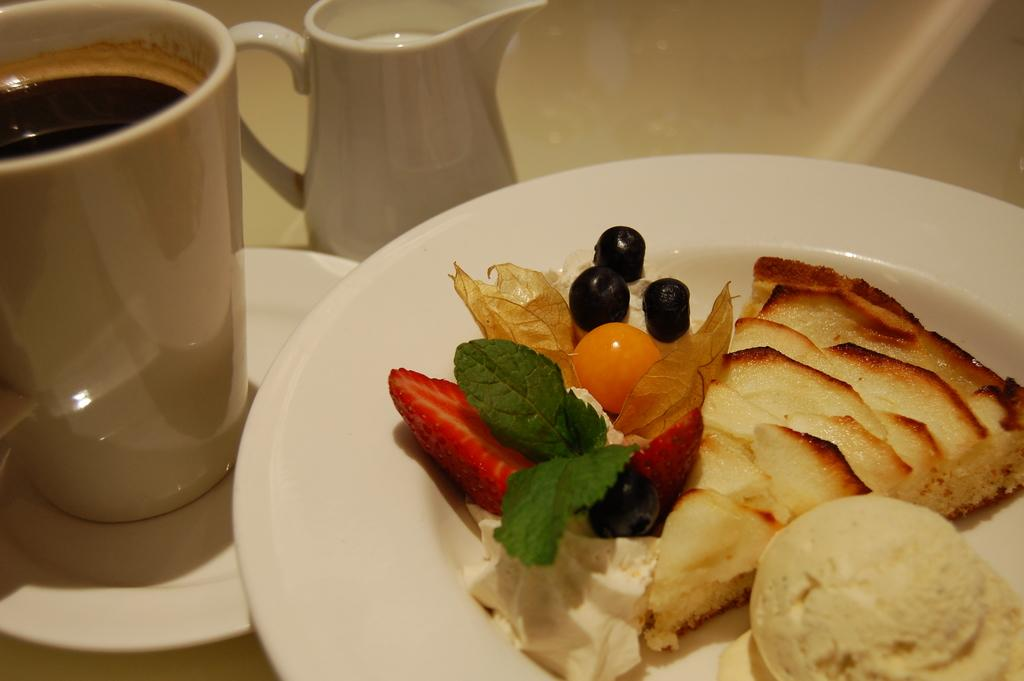What can be seen on the plate in the image? There are food items on a plate in the image. What is the cup and saucer used for in the image? The cup with a saucer is likely used for holding a beverage in the image. What is the liquid in the cup? There is some liquid in the cup, but the specific type of liquid is not mentioned in the facts. What is the jug used for in the image? The jug with some liquid is likely used for pouring the liquid into the cup or onto the food items. What direction does the yoke face in the image? There is no yoke present in the image, so it is not possible to determine the direction it might be facing. 